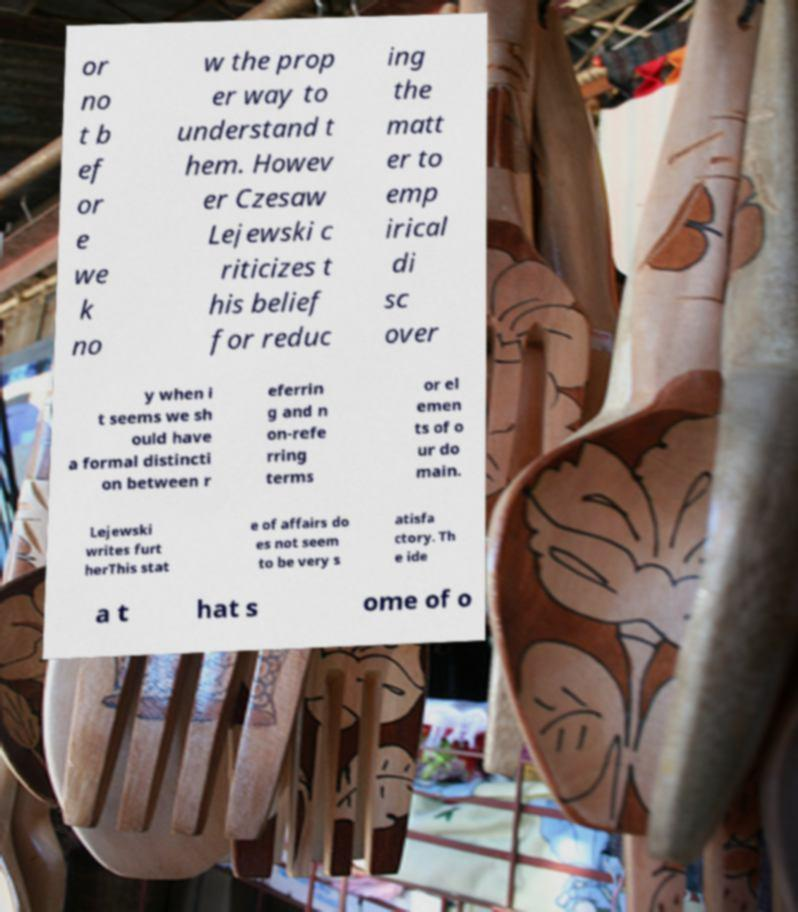Could you assist in decoding the text presented in this image and type it out clearly? or no t b ef or e we k no w the prop er way to understand t hem. Howev er Czesaw Lejewski c riticizes t his belief for reduc ing the matt er to emp irical di sc over y when i t seems we sh ould have a formal distincti on between r eferrin g and n on-refe rring terms or el emen ts of o ur do main. Lejewski writes furt herThis stat e of affairs do es not seem to be very s atisfa ctory. Th e ide a t hat s ome of o 